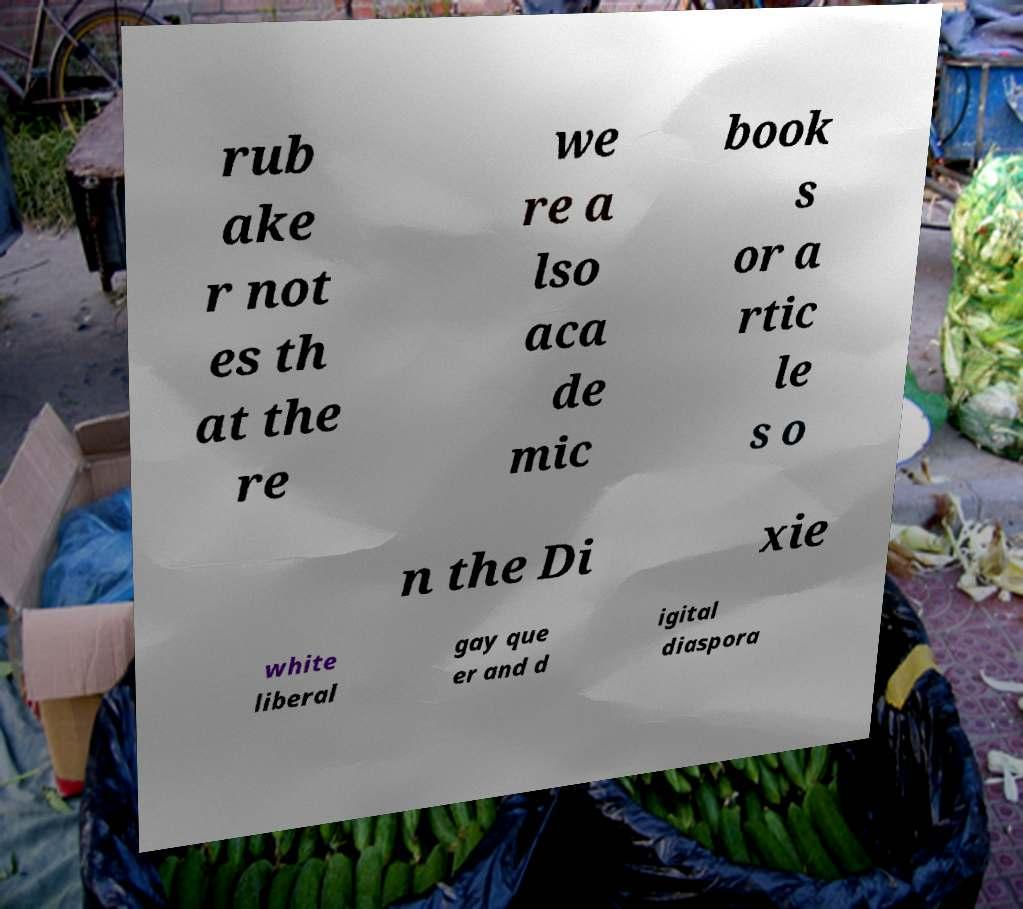Can you accurately transcribe the text from the provided image for me? rub ake r not es th at the re we re a lso aca de mic book s or a rtic le s o n the Di xie white liberal gay que er and d igital diaspora 